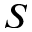<formula> <loc_0><loc_0><loc_500><loc_500>S</formula> 